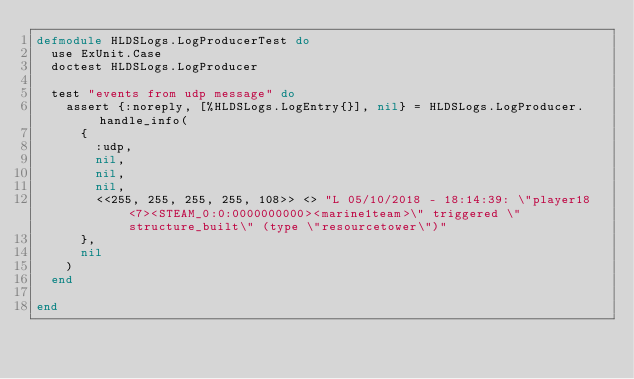<code> <loc_0><loc_0><loc_500><loc_500><_Elixir_>defmodule HLDSLogs.LogProducerTest do
  use ExUnit.Case
  doctest HLDSLogs.LogProducer

  test "events from udp message" do
    assert {:noreply, [%HLDSLogs.LogEntry{}], nil} = HLDSLogs.LogProducer.handle_info(
      {
        :udp,
        nil,
        nil,
        nil,
        <<255, 255, 255, 255, 108>> <> "L 05/10/2018 - 18:14:39: \"player18<7><STEAM_0:0:0000000000><marine1team>\" triggered \"structure_built\" (type \"resourcetower\")"
      },
      nil
    )
  end

end</code> 